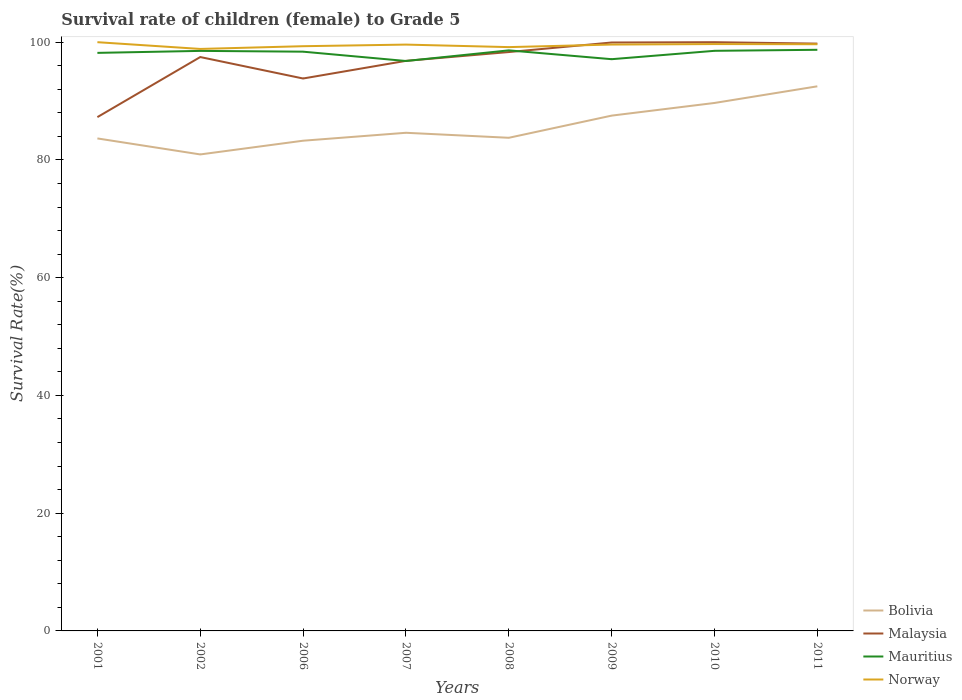How many different coloured lines are there?
Offer a very short reply. 4. Is the number of lines equal to the number of legend labels?
Give a very brief answer. Yes. Across all years, what is the maximum survival rate of female children to grade 5 in Norway?
Provide a short and direct response. 98.85. In which year was the survival rate of female children to grade 5 in Mauritius maximum?
Make the answer very short. 2007. What is the total survival rate of female children to grade 5 in Norway in the graph?
Your response must be concise. -0.06. What is the difference between the highest and the second highest survival rate of female children to grade 5 in Bolivia?
Your answer should be very brief. 11.57. What is the difference between two consecutive major ticks on the Y-axis?
Your response must be concise. 20. Where does the legend appear in the graph?
Make the answer very short. Bottom right. How many legend labels are there?
Your answer should be compact. 4. How are the legend labels stacked?
Keep it short and to the point. Vertical. What is the title of the graph?
Make the answer very short. Survival rate of children (female) to Grade 5. Does "Finland" appear as one of the legend labels in the graph?
Offer a very short reply. No. What is the label or title of the Y-axis?
Offer a terse response. Survival Rate(%). What is the Survival Rate(%) of Bolivia in 2001?
Offer a very short reply. 83.65. What is the Survival Rate(%) of Malaysia in 2001?
Offer a very short reply. 87.27. What is the Survival Rate(%) in Mauritius in 2001?
Ensure brevity in your answer.  98.19. What is the Survival Rate(%) of Bolivia in 2002?
Your response must be concise. 80.94. What is the Survival Rate(%) in Malaysia in 2002?
Your answer should be compact. 97.48. What is the Survival Rate(%) of Mauritius in 2002?
Offer a terse response. 98.52. What is the Survival Rate(%) of Norway in 2002?
Give a very brief answer. 98.85. What is the Survival Rate(%) of Bolivia in 2006?
Your response must be concise. 83.26. What is the Survival Rate(%) in Malaysia in 2006?
Offer a terse response. 93.83. What is the Survival Rate(%) in Mauritius in 2006?
Provide a succinct answer. 98.39. What is the Survival Rate(%) of Norway in 2006?
Give a very brief answer. 99.32. What is the Survival Rate(%) in Bolivia in 2007?
Your answer should be compact. 84.61. What is the Survival Rate(%) of Malaysia in 2007?
Your response must be concise. 96.83. What is the Survival Rate(%) in Mauritius in 2007?
Provide a short and direct response. 96.81. What is the Survival Rate(%) in Norway in 2007?
Ensure brevity in your answer.  99.59. What is the Survival Rate(%) in Bolivia in 2008?
Keep it short and to the point. 83.76. What is the Survival Rate(%) in Malaysia in 2008?
Your response must be concise. 98.32. What is the Survival Rate(%) of Mauritius in 2008?
Your answer should be compact. 98.61. What is the Survival Rate(%) in Norway in 2008?
Offer a very short reply. 99.16. What is the Survival Rate(%) in Bolivia in 2009?
Offer a terse response. 87.53. What is the Survival Rate(%) of Malaysia in 2009?
Give a very brief answer. 99.95. What is the Survival Rate(%) in Mauritius in 2009?
Offer a terse response. 97.11. What is the Survival Rate(%) in Norway in 2009?
Your answer should be compact. 99.6. What is the Survival Rate(%) of Bolivia in 2010?
Offer a very short reply. 89.68. What is the Survival Rate(%) in Mauritius in 2010?
Give a very brief answer. 98.53. What is the Survival Rate(%) of Norway in 2010?
Your answer should be compact. 99.68. What is the Survival Rate(%) in Bolivia in 2011?
Offer a terse response. 92.5. What is the Survival Rate(%) in Malaysia in 2011?
Offer a very short reply. 99.76. What is the Survival Rate(%) of Mauritius in 2011?
Provide a short and direct response. 98.71. What is the Survival Rate(%) of Norway in 2011?
Keep it short and to the point. 99.65. Across all years, what is the maximum Survival Rate(%) in Bolivia?
Make the answer very short. 92.5. Across all years, what is the maximum Survival Rate(%) in Malaysia?
Provide a short and direct response. 100. Across all years, what is the maximum Survival Rate(%) of Mauritius?
Ensure brevity in your answer.  98.71. Across all years, what is the maximum Survival Rate(%) in Norway?
Give a very brief answer. 100. Across all years, what is the minimum Survival Rate(%) in Bolivia?
Provide a short and direct response. 80.94. Across all years, what is the minimum Survival Rate(%) in Malaysia?
Your answer should be very brief. 87.27. Across all years, what is the minimum Survival Rate(%) in Mauritius?
Keep it short and to the point. 96.81. Across all years, what is the minimum Survival Rate(%) of Norway?
Your answer should be compact. 98.85. What is the total Survival Rate(%) of Bolivia in the graph?
Ensure brevity in your answer.  685.94. What is the total Survival Rate(%) in Malaysia in the graph?
Your answer should be very brief. 773.44. What is the total Survival Rate(%) in Mauritius in the graph?
Keep it short and to the point. 784.87. What is the total Survival Rate(%) in Norway in the graph?
Make the answer very short. 795.86. What is the difference between the Survival Rate(%) in Bolivia in 2001 and that in 2002?
Offer a very short reply. 2.72. What is the difference between the Survival Rate(%) of Malaysia in 2001 and that in 2002?
Offer a terse response. -10.2. What is the difference between the Survival Rate(%) of Mauritius in 2001 and that in 2002?
Your answer should be compact. -0.34. What is the difference between the Survival Rate(%) of Norway in 2001 and that in 2002?
Your response must be concise. 1.15. What is the difference between the Survival Rate(%) of Bolivia in 2001 and that in 2006?
Keep it short and to the point. 0.39. What is the difference between the Survival Rate(%) of Malaysia in 2001 and that in 2006?
Offer a terse response. -6.56. What is the difference between the Survival Rate(%) in Mauritius in 2001 and that in 2006?
Offer a very short reply. -0.2. What is the difference between the Survival Rate(%) in Norway in 2001 and that in 2006?
Ensure brevity in your answer.  0.68. What is the difference between the Survival Rate(%) of Bolivia in 2001 and that in 2007?
Your response must be concise. -0.96. What is the difference between the Survival Rate(%) in Malaysia in 2001 and that in 2007?
Provide a short and direct response. -9.56. What is the difference between the Survival Rate(%) of Mauritius in 2001 and that in 2007?
Make the answer very short. 1.38. What is the difference between the Survival Rate(%) in Norway in 2001 and that in 2007?
Keep it short and to the point. 0.41. What is the difference between the Survival Rate(%) in Bolivia in 2001 and that in 2008?
Make the answer very short. -0.11. What is the difference between the Survival Rate(%) of Malaysia in 2001 and that in 2008?
Your answer should be compact. -11.05. What is the difference between the Survival Rate(%) of Mauritius in 2001 and that in 2008?
Make the answer very short. -0.42. What is the difference between the Survival Rate(%) in Norway in 2001 and that in 2008?
Make the answer very short. 0.84. What is the difference between the Survival Rate(%) of Bolivia in 2001 and that in 2009?
Make the answer very short. -3.88. What is the difference between the Survival Rate(%) in Malaysia in 2001 and that in 2009?
Your response must be concise. -12.67. What is the difference between the Survival Rate(%) in Mauritius in 2001 and that in 2009?
Provide a succinct answer. 1.07. What is the difference between the Survival Rate(%) of Norway in 2001 and that in 2009?
Your answer should be very brief. 0.4. What is the difference between the Survival Rate(%) of Bolivia in 2001 and that in 2010?
Your response must be concise. -6.02. What is the difference between the Survival Rate(%) in Malaysia in 2001 and that in 2010?
Keep it short and to the point. -12.73. What is the difference between the Survival Rate(%) in Mauritius in 2001 and that in 2010?
Provide a succinct answer. -0.35. What is the difference between the Survival Rate(%) of Norway in 2001 and that in 2010?
Your response must be concise. 0.32. What is the difference between the Survival Rate(%) of Bolivia in 2001 and that in 2011?
Offer a terse response. -8.85. What is the difference between the Survival Rate(%) of Malaysia in 2001 and that in 2011?
Offer a very short reply. -12.48. What is the difference between the Survival Rate(%) of Mauritius in 2001 and that in 2011?
Make the answer very short. -0.52. What is the difference between the Survival Rate(%) of Norway in 2001 and that in 2011?
Offer a terse response. 0.35. What is the difference between the Survival Rate(%) of Bolivia in 2002 and that in 2006?
Your answer should be compact. -2.33. What is the difference between the Survival Rate(%) of Malaysia in 2002 and that in 2006?
Provide a short and direct response. 3.64. What is the difference between the Survival Rate(%) of Mauritius in 2002 and that in 2006?
Offer a very short reply. 0.13. What is the difference between the Survival Rate(%) of Norway in 2002 and that in 2006?
Provide a succinct answer. -0.46. What is the difference between the Survival Rate(%) in Bolivia in 2002 and that in 2007?
Provide a short and direct response. -3.68. What is the difference between the Survival Rate(%) of Malaysia in 2002 and that in 2007?
Your answer should be very brief. 0.65. What is the difference between the Survival Rate(%) in Mauritius in 2002 and that in 2007?
Ensure brevity in your answer.  1.72. What is the difference between the Survival Rate(%) in Norway in 2002 and that in 2007?
Offer a terse response. -0.74. What is the difference between the Survival Rate(%) of Bolivia in 2002 and that in 2008?
Ensure brevity in your answer.  -2.83. What is the difference between the Survival Rate(%) of Malaysia in 2002 and that in 2008?
Keep it short and to the point. -0.85. What is the difference between the Survival Rate(%) in Mauritius in 2002 and that in 2008?
Offer a very short reply. -0.09. What is the difference between the Survival Rate(%) in Norway in 2002 and that in 2008?
Your response must be concise. -0.31. What is the difference between the Survival Rate(%) in Bolivia in 2002 and that in 2009?
Keep it short and to the point. -6.59. What is the difference between the Survival Rate(%) of Malaysia in 2002 and that in 2009?
Offer a very short reply. -2.47. What is the difference between the Survival Rate(%) in Mauritius in 2002 and that in 2009?
Offer a very short reply. 1.41. What is the difference between the Survival Rate(%) of Norway in 2002 and that in 2009?
Offer a very short reply. -0.74. What is the difference between the Survival Rate(%) of Bolivia in 2002 and that in 2010?
Ensure brevity in your answer.  -8.74. What is the difference between the Survival Rate(%) in Malaysia in 2002 and that in 2010?
Ensure brevity in your answer.  -2.52. What is the difference between the Survival Rate(%) of Mauritius in 2002 and that in 2010?
Make the answer very short. -0.01. What is the difference between the Survival Rate(%) of Norway in 2002 and that in 2010?
Provide a short and direct response. -0.83. What is the difference between the Survival Rate(%) of Bolivia in 2002 and that in 2011?
Ensure brevity in your answer.  -11.57. What is the difference between the Survival Rate(%) in Malaysia in 2002 and that in 2011?
Provide a succinct answer. -2.28. What is the difference between the Survival Rate(%) in Mauritius in 2002 and that in 2011?
Offer a very short reply. -0.19. What is the difference between the Survival Rate(%) in Norway in 2002 and that in 2011?
Keep it short and to the point. -0.8. What is the difference between the Survival Rate(%) of Bolivia in 2006 and that in 2007?
Your response must be concise. -1.35. What is the difference between the Survival Rate(%) of Malaysia in 2006 and that in 2007?
Your response must be concise. -3. What is the difference between the Survival Rate(%) in Mauritius in 2006 and that in 2007?
Make the answer very short. 1.58. What is the difference between the Survival Rate(%) of Norway in 2006 and that in 2007?
Offer a terse response. -0.27. What is the difference between the Survival Rate(%) in Bolivia in 2006 and that in 2008?
Your answer should be compact. -0.5. What is the difference between the Survival Rate(%) of Malaysia in 2006 and that in 2008?
Your answer should be compact. -4.49. What is the difference between the Survival Rate(%) in Mauritius in 2006 and that in 2008?
Your response must be concise. -0.22. What is the difference between the Survival Rate(%) of Norway in 2006 and that in 2008?
Provide a succinct answer. 0.15. What is the difference between the Survival Rate(%) in Bolivia in 2006 and that in 2009?
Your answer should be very brief. -4.26. What is the difference between the Survival Rate(%) of Malaysia in 2006 and that in 2009?
Keep it short and to the point. -6.11. What is the difference between the Survival Rate(%) of Mauritius in 2006 and that in 2009?
Offer a terse response. 1.28. What is the difference between the Survival Rate(%) of Norway in 2006 and that in 2009?
Provide a short and direct response. -0.28. What is the difference between the Survival Rate(%) of Bolivia in 2006 and that in 2010?
Your response must be concise. -6.41. What is the difference between the Survival Rate(%) in Malaysia in 2006 and that in 2010?
Ensure brevity in your answer.  -6.17. What is the difference between the Survival Rate(%) of Mauritius in 2006 and that in 2010?
Offer a terse response. -0.15. What is the difference between the Survival Rate(%) of Norway in 2006 and that in 2010?
Your answer should be very brief. -0.36. What is the difference between the Survival Rate(%) of Bolivia in 2006 and that in 2011?
Ensure brevity in your answer.  -9.24. What is the difference between the Survival Rate(%) in Malaysia in 2006 and that in 2011?
Provide a short and direct response. -5.93. What is the difference between the Survival Rate(%) in Mauritius in 2006 and that in 2011?
Ensure brevity in your answer.  -0.32. What is the difference between the Survival Rate(%) in Norway in 2006 and that in 2011?
Provide a short and direct response. -0.33. What is the difference between the Survival Rate(%) in Bolivia in 2007 and that in 2008?
Ensure brevity in your answer.  0.85. What is the difference between the Survival Rate(%) in Malaysia in 2007 and that in 2008?
Offer a terse response. -1.49. What is the difference between the Survival Rate(%) of Mauritius in 2007 and that in 2008?
Make the answer very short. -1.8. What is the difference between the Survival Rate(%) in Norway in 2007 and that in 2008?
Your response must be concise. 0.43. What is the difference between the Survival Rate(%) in Bolivia in 2007 and that in 2009?
Offer a terse response. -2.92. What is the difference between the Survival Rate(%) in Malaysia in 2007 and that in 2009?
Your answer should be very brief. -3.12. What is the difference between the Survival Rate(%) of Mauritius in 2007 and that in 2009?
Offer a terse response. -0.31. What is the difference between the Survival Rate(%) of Norway in 2007 and that in 2009?
Your answer should be very brief. -0.01. What is the difference between the Survival Rate(%) of Bolivia in 2007 and that in 2010?
Offer a terse response. -5.06. What is the difference between the Survival Rate(%) in Malaysia in 2007 and that in 2010?
Offer a terse response. -3.17. What is the difference between the Survival Rate(%) of Mauritius in 2007 and that in 2010?
Offer a very short reply. -1.73. What is the difference between the Survival Rate(%) of Norway in 2007 and that in 2010?
Give a very brief answer. -0.09. What is the difference between the Survival Rate(%) in Bolivia in 2007 and that in 2011?
Make the answer very short. -7.89. What is the difference between the Survival Rate(%) of Malaysia in 2007 and that in 2011?
Ensure brevity in your answer.  -2.93. What is the difference between the Survival Rate(%) of Mauritius in 2007 and that in 2011?
Provide a short and direct response. -1.9. What is the difference between the Survival Rate(%) in Norway in 2007 and that in 2011?
Ensure brevity in your answer.  -0.06. What is the difference between the Survival Rate(%) in Bolivia in 2008 and that in 2009?
Your response must be concise. -3.77. What is the difference between the Survival Rate(%) of Malaysia in 2008 and that in 2009?
Offer a very short reply. -1.62. What is the difference between the Survival Rate(%) of Mauritius in 2008 and that in 2009?
Your answer should be very brief. 1.5. What is the difference between the Survival Rate(%) of Norway in 2008 and that in 2009?
Your answer should be very brief. -0.44. What is the difference between the Survival Rate(%) of Bolivia in 2008 and that in 2010?
Your answer should be compact. -5.91. What is the difference between the Survival Rate(%) of Malaysia in 2008 and that in 2010?
Offer a very short reply. -1.68. What is the difference between the Survival Rate(%) of Mauritius in 2008 and that in 2010?
Offer a very short reply. 0.08. What is the difference between the Survival Rate(%) in Norway in 2008 and that in 2010?
Ensure brevity in your answer.  -0.52. What is the difference between the Survival Rate(%) in Bolivia in 2008 and that in 2011?
Make the answer very short. -8.74. What is the difference between the Survival Rate(%) of Malaysia in 2008 and that in 2011?
Make the answer very short. -1.43. What is the difference between the Survival Rate(%) in Mauritius in 2008 and that in 2011?
Offer a terse response. -0.1. What is the difference between the Survival Rate(%) of Norway in 2008 and that in 2011?
Your answer should be very brief. -0.49. What is the difference between the Survival Rate(%) of Bolivia in 2009 and that in 2010?
Make the answer very short. -2.15. What is the difference between the Survival Rate(%) of Malaysia in 2009 and that in 2010?
Provide a succinct answer. -0.05. What is the difference between the Survival Rate(%) in Mauritius in 2009 and that in 2010?
Give a very brief answer. -1.42. What is the difference between the Survival Rate(%) in Norway in 2009 and that in 2010?
Your answer should be compact. -0.08. What is the difference between the Survival Rate(%) of Bolivia in 2009 and that in 2011?
Provide a short and direct response. -4.98. What is the difference between the Survival Rate(%) of Malaysia in 2009 and that in 2011?
Ensure brevity in your answer.  0.19. What is the difference between the Survival Rate(%) of Mauritius in 2009 and that in 2011?
Provide a short and direct response. -1.6. What is the difference between the Survival Rate(%) of Norway in 2009 and that in 2011?
Make the answer very short. -0.05. What is the difference between the Survival Rate(%) of Bolivia in 2010 and that in 2011?
Your answer should be very brief. -2.83. What is the difference between the Survival Rate(%) in Malaysia in 2010 and that in 2011?
Offer a terse response. 0.24. What is the difference between the Survival Rate(%) in Mauritius in 2010 and that in 2011?
Your answer should be very brief. -0.17. What is the difference between the Survival Rate(%) in Norway in 2010 and that in 2011?
Your response must be concise. 0.03. What is the difference between the Survival Rate(%) in Bolivia in 2001 and the Survival Rate(%) in Malaysia in 2002?
Give a very brief answer. -13.82. What is the difference between the Survival Rate(%) in Bolivia in 2001 and the Survival Rate(%) in Mauritius in 2002?
Offer a terse response. -14.87. What is the difference between the Survival Rate(%) in Bolivia in 2001 and the Survival Rate(%) in Norway in 2002?
Your answer should be very brief. -15.2. What is the difference between the Survival Rate(%) of Malaysia in 2001 and the Survival Rate(%) of Mauritius in 2002?
Your answer should be very brief. -11.25. What is the difference between the Survival Rate(%) in Malaysia in 2001 and the Survival Rate(%) in Norway in 2002?
Give a very brief answer. -11.58. What is the difference between the Survival Rate(%) in Mauritius in 2001 and the Survival Rate(%) in Norway in 2002?
Keep it short and to the point. -0.67. What is the difference between the Survival Rate(%) in Bolivia in 2001 and the Survival Rate(%) in Malaysia in 2006?
Your answer should be compact. -10.18. What is the difference between the Survival Rate(%) in Bolivia in 2001 and the Survival Rate(%) in Mauritius in 2006?
Offer a terse response. -14.74. What is the difference between the Survival Rate(%) of Bolivia in 2001 and the Survival Rate(%) of Norway in 2006?
Your answer should be very brief. -15.66. What is the difference between the Survival Rate(%) of Malaysia in 2001 and the Survival Rate(%) of Mauritius in 2006?
Your answer should be very brief. -11.12. What is the difference between the Survival Rate(%) of Malaysia in 2001 and the Survival Rate(%) of Norway in 2006?
Your answer should be very brief. -12.04. What is the difference between the Survival Rate(%) in Mauritius in 2001 and the Survival Rate(%) in Norway in 2006?
Provide a succinct answer. -1.13. What is the difference between the Survival Rate(%) in Bolivia in 2001 and the Survival Rate(%) in Malaysia in 2007?
Provide a succinct answer. -13.18. What is the difference between the Survival Rate(%) in Bolivia in 2001 and the Survival Rate(%) in Mauritius in 2007?
Your response must be concise. -13.15. What is the difference between the Survival Rate(%) of Bolivia in 2001 and the Survival Rate(%) of Norway in 2007?
Provide a succinct answer. -15.94. What is the difference between the Survival Rate(%) of Malaysia in 2001 and the Survival Rate(%) of Mauritius in 2007?
Give a very brief answer. -9.53. What is the difference between the Survival Rate(%) in Malaysia in 2001 and the Survival Rate(%) in Norway in 2007?
Provide a short and direct response. -12.32. What is the difference between the Survival Rate(%) in Mauritius in 2001 and the Survival Rate(%) in Norway in 2007?
Your response must be concise. -1.41. What is the difference between the Survival Rate(%) in Bolivia in 2001 and the Survival Rate(%) in Malaysia in 2008?
Your answer should be very brief. -14.67. What is the difference between the Survival Rate(%) of Bolivia in 2001 and the Survival Rate(%) of Mauritius in 2008?
Keep it short and to the point. -14.96. What is the difference between the Survival Rate(%) in Bolivia in 2001 and the Survival Rate(%) in Norway in 2008?
Provide a short and direct response. -15.51. What is the difference between the Survival Rate(%) in Malaysia in 2001 and the Survival Rate(%) in Mauritius in 2008?
Provide a short and direct response. -11.34. What is the difference between the Survival Rate(%) in Malaysia in 2001 and the Survival Rate(%) in Norway in 2008?
Ensure brevity in your answer.  -11.89. What is the difference between the Survival Rate(%) of Mauritius in 2001 and the Survival Rate(%) of Norway in 2008?
Give a very brief answer. -0.98. What is the difference between the Survival Rate(%) of Bolivia in 2001 and the Survival Rate(%) of Malaysia in 2009?
Your answer should be compact. -16.29. What is the difference between the Survival Rate(%) of Bolivia in 2001 and the Survival Rate(%) of Mauritius in 2009?
Your answer should be very brief. -13.46. What is the difference between the Survival Rate(%) of Bolivia in 2001 and the Survival Rate(%) of Norway in 2009?
Give a very brief answer. -15.95. What is the difference between the Survival Rate(%) of Malaysia in 2001 and the Survival Rate(%) of Mauritius in 2009?
Keep it short and to the point. -9.84. What is the difference between the Survival Rate(%) of Malaysia in 2001 and the Survival Rate(%) of Norway in 2009?
Ensure brevity in your answer.  -12.33. What is the difference between the Survival Rate(%) of Mauritius in 2001 and the Survival Rate(%) of Norway in 2009?
Make the answer very short. -1.41. What is the difference between the Survival Rate(%) in Bolivia in 2001 and the Survival Rate(%) in Malaysia in 2010?
Your response must be concise. -16.35. What is the difference between the Survival Rate(%) of Bolivia in 2001 and the Survival Rate(%) of Mauritius in 2010?
Keep it short and to the point. -14.88. What is the difference between the Survival Rate(%) in Bolivia in 2001 and the Survival Rate(%) in Norway in 2010?
Your answer should be very brief. -16.03. What is the difference between the Survival Rate(%) of Malaysia in 2001 and the Survival Rate(%) of Mauritius in 2010?
Keep it short and to the point. -11.26. What is the difference between the Survival Rate(%) of Malaysia in 2001 and the Survival Rate(%) of Norway in 2010?
Offer a terse response. -12.41. What is the difference between the Survival Rate(%) of Mauritius in 2001 and the Survival Rate(%) of Norway in 2010?
Your answer should be compact. -1.49. What is the difference between the Survival Rate(%) in Bolivia in 2001 and the Survival Rate(%) in Malaysia in 2011?
Ensure brevity in your answer.  -16.1. What is the difference between the Survival Rate(%) of Bolivia in 2001 and the Survival Rate(%) of Mauritius in 2011?
Offer a very short reply. -15.06. What is the difference between the Survival Rate(%) of Bolivia in 2001 and the Survival Rate(%) of Norway in 2011?
Keep it short and to the point. -16. What is the difference between the Survival Rate(%) of Malaysia in 2001 and the Survival Rate(%) of Mauritius in 2011?
Your answer should be compact. -11.44. What is the difference between the Survival Rate(%) in Malaysia in 2001 and the Survival Rate(%) in Norway in 2011?
Keep it short and to the point. -12.38. What is the difference between the Survival Rate(%) in Mauritius in 2001 and the Survival Rate(%) in Norway in 2011?
Provide a succinct answer. -1.47. What is the difference between the Survival Rate(%) in Bolivia in 2002 and the Survival Rate(%) in Malaysia in 2006?
Your response must be concise. -12.9. What is the difference between the Survival Rate(%) of Bolivia in 2002 and the Survival Rate(%) of Mauritius in 2006?
Your answer should be compact. -17.45. What is the difference between the Survival Rate(%) of Bolivia in 2002 and the Survival Rate(%) of Norway in 2006?
Keep it short and to the point. -18.38. What is the difference between the Survival Rate(%) in Malaysia in 2002 and the Survival Rate(%) in Mauritius in 2006?
Offer a terse response. -0.91. What is the difference between the Survival Rate(%) of Malaysia in 2002 and the Survival Rate(%) of Norway in 2006?
Keep it short and to the point. -1.84. What is the difference between the Survival Rate(%) in Mauritius in 2002 and the Survival Rate(%) in Norway in 2006?
Provide a succinct answer. -0.79. What is the difference between the Survival Rate(%) of Bolivia in 2002 and the Survival Rate(%) of Malaysia in 2007?
Offer a terse response. -15.89. What is the difference between the Survival Rate(%) in Bolivia in 2002 and the Survival Rate(%) in Mauritius in 2007?
Your answer should be very brief. -15.87. What is the difference between the Survival Rate(%) of Bolivia in 2002 and the Survival Rate(%) of Norway in 2007?
Your answer should be very brief. -18.66. What is the difference between the Survival Rate(%) in Malaysia in 2002 and the Survival Rate(%) in Mauritius in 2007?
Keep it short and to the point. 0.67. What is the difference between the Survival Rate(%) of Malaysia in 2002 and the Survival Rate(%) of Norway in 2007?
Keep it short and to the point. -2.12. What is the difference between the Survival Rate(%) of Mauritius in 2002 and the Survival Rate(%) of Norway in 2007?
Give a very brief answer. -1.07. What is the difference between the Survival Rate(%) in Bolivia in 2002 and the Survival Rate(%) in Malaysia in 2008?
Provide a short and direct response. -17.39. What is the difference between the Survival Rate(%) in Bolivia in 2002 and the Survival Rate(%) in Mauritius in 2008?
Provide a succinct answer. -17.67. What is the difference between the Survival Rate(%) of Bolivia in 2002 and the Survival Rate(%) of Norway in 2008?
Offer a terse response. -18.23. What is the difference between the Survival Rate(%) in Malaysia in 2002 and the Survival Rate(%) in Mauritius in 2008?
Your response must be concise. -1.13. What is the difference between the Survival Rate(%) in Malaysia in 2002 and the Survival Rate(%) in Norway in 2008?
Provide a succinct answer. -1.69. What is the difference between the Survival Rate(%) of Mauritius in 2002 and the Survival Rate(%) of Norway in 2008?
Offer a very short reply. -0.64. What is the difference between the Survival Rate(%) in Bolivia in 2002 and the Survival Rate(%) in Malaysia in 2009?
Your answer should be compact. -19.01. What is the difference between the Survival Rate(%) of Bolivia in 2002 and the Survival Rate(%) of Mauritius in 2009?
Ensure brevity in your answer.  -16.18. What is the difference between the Survival Rate(%) of Bolivia in 2002 and the Survival Rate(%) of Norway in 2009?
Offer a very short reply. -18.66. What is the difference between the Survival Rate(%) in Malaysia in 2002 and the Survival Rate(%) in Mauritius in 2009?
Offer a very short reply. 0.36. What is the difference between the Survival Rate(%) of Malaysia in 2002 and the Survival Rate(%) of Norway in 2009?
Provide a short and direct response. -2.12. What is the difference between the Survival Rate(%) in Mauritius in 2002 and the Survival Rate(%) in Norway in 2009?
Provide a short and direct response. -1.08. What is the difference between the Survival Rate(%) in Bolivia in 2002 and the Survival Rate(%) in Malaysia in 2010?
Make the answer very short. -19.06. What is the difference between the Survival Rate(%) in Bolivia in 2002 and the Survival Rate(%) in Mauritius in 2010?
Offer a terse response. -17.6. What is the difference between the Survival Rate(%) of Bolivia in 2002 and the Survival Rate(%) of Norway in 2010?
Your answer should be compact. -18.74. What is the difference between the Survival Rate(%) of Malaysia in 2002 and the Survival Rate(%) of Mauritius in 2010?
Offer a very short reply. -1.06. What is the difference between the Survival Rate(%) of Malaysia in 2002 and the Survival Rate(%) of Norway in 2010?
Offer a terse response. -2.2. What is the difference between the Survival Rate(%) in Mauritius in 2002 and the Survival Rate(%) in Norway in 2010?
Provide a short and direct response. -1.16. What is the difference between the Survival Rate(%) in Bolivia in 2002 and the Survival Rate(%) in Malaysia in 2011?
Your response must be concise. -18.82. What is the difference between the Survival Rate(%) in Bolivia in 2002 and the Survival Rate(%) in Mauritius in 2011?
Give a very brief answer. -17.77. What is the difference between the Survival Rate(%) in Bolivia in 2002 and the Survival Rate(%) in Norway in 2011?
Offer a very short reply. -18.72. What is the difference between the Survival Rate(%) of Malaysia in 2002 and the Survival Rate(%) of Mauritius in 2011?
Provide a succinct answer. -1.23. What is the difference between the Survival Rate(%) of Malaysia in 2002 and the Survival Rate(%) of Norway in 2011?
Provide a short and direct response. -2.18. What is the difference between the Survival Rate(%) of Mauritius in 2002 and the Survival Rate(%) of Norway in 2011?
Provide a succinct answer. -1.13. What is the difference between the Survival Rate(%) of Bolivia in 2006 and the Survival Rate(%) of Malaysia in 2007?
Make the answer very short. -13.56. What is the difference between the Survival Rate(%) in Bolivia in 2006 and the Survival Rate(%) in Mauritius in 2007?
Your response must be concise. -13.54. What is the difference between the Survival Rate(%) of Bolivia in 2006 and the Survival Rate(%) of Norway in 2007?
Provide a short and direct response. -16.33. What is the difference between the Survival Rate(%) in Malaysia in 2006 and the Survival Rate(%) in Mauritius in 2007?
Give a very brief answer. -2.97. What is the difference between the Survival Rate(%) of Malaysia in 2006 and the Survival Rate(%) of Norway in 2007?
Provide a short and direct response. -5.76. What is the difference between the Survival Rate(%) of Mauritius in 2006 and the Survival Rate(%) of Norway in 2007?
Your answer should be compact. -1.2. What is the difference between the Survival Rate(%) in Bolivia in 2006 and the Survival Rate(%) in Malaysia in 2008?
Offer a terse response. -15.06. What is the difference between the Survival Rate(%) in Bolivia in 2006 and the Survival Rate(%) in Mauritius in 2008?
Offer a very short reply. -15.34. What is the difference between the Survival Rate(%) of Bolivia in 2006 and the Survival Rate(%) of Norway in 2008?
Your answer should be compact. -15.9. What is the difference between the Survival Rate(%) in Malaysia in 2006 and the Survival Rate(%) in Mauritius in 2008?
Your answer should be very brief. -4.78. What is the difference between the Survival Rate(%) of Malaysia in 2006 and the Survival Rate(%) of Norway in 2008?
Ensure brevity in your answer.  -5.33. What is the difference between the Survival Rate(%) of Mauritius in 2006 and the Survival Rate(%) of Norway in 2008?
Keep it short and to the point. -0.78. What is the difference between the Survival Rate(%) of Bolivia in 2006 and the Survival Rate(%) of Malaysia in 2009?
Offer a very short reply. -16.68. What is the difference between the Survival Rate(%) of Bolivia in 2006 and the Survival Rate(%) of Mauritius in 2009?
Provide a short and direct response. -13.85. What is the difference between the Survival Rate(%) of Bolivia in 2006 and the Survival Rate(%) of Norway in 2009?
Your answer should be very brief. -16.33. What is the difference between the Survival Rate(%) in Malaysia in 2006 and the Survival Rate(%) in Mauritius in 2009?
Ensure brevity in your answer.  -3.28. What is the difference between the Survival Rate(%) of Malaysia in 2006 and the Survival Rate(%) of Norway in 2009?
Offer a very short reply. -5.77. What is the difference between the Survival Rate(%) of Mauritius in 2006 and the Survival Rate(%) of Norway in 2009?
Provide a succinct answer. -1.21. What is the difference between the Survival Rate(%) of Bolivia in 2006 and the Survival Rate(%) of Malaysia in 2010?
Your answer should be compact. -16.74. What is the difference between the Survival Rate(%) of Bolivia in 2006 and the Survival Rate(%) of Mauritius in 2010?
Offer a terse response. -15.27. What is the difference between the Survival Rate(%) of Bolivia in 2006 and the Survival Rate(%) of Norway in 2010?
Provide a short and direct response. -16.42. What is the difference between the Survival Rate(%) of Malaysia in 2006 and the Survival Rate(%) of Mauritius in 2010?
Keep it short and to the point. -4.7. What is the difference between the Survival Rate(%) in Malaysia in 2006 and the Survival Rate(%) in Norway in 2010?
Offer a terse response. -5.85. What is the difference between the Survival Rate(%) of Mauritius in 2006 and the Survival Rate(%) of Norway in 2010?
Your answer should be compact. -1.29. What is the difference between the Survival Rate(%) of Bolivia in 2006 and the Survival Rate(%) of Malaysia in 2011?
Your response must be concise. -16.49. What is the difference between the Survival Rate(%) of Bolivia in 2006 and the Survival Rate(%) of Mauritius in 2011?
Provide a succinct answer. -15.44. What is the difference between the Survival Rate(%) of Bolivia in 2006 and the Survival Rate(%) of Norway in 2011?
Ensure brevity in your answer.  -16.39. What is the difference between the Survival Rate(%) of Malaysia in 2006 and the Survival Rate(%) of Mauritius in 2011?
Ensure brevity in your answer.  -4.88. What is the difference between the Survival Rate(%) of Malaysia in 2006 and the Survival Rate(%) of Norway in 2011?
Ensure brevity in your answer.  -5.82. What is the difference between the Survival Rate(%) of Mauritius in 2006 and the Survival Rate(%) of Norway in 2011?
Keep it short and to the point. -1.26. What is the difference between the Survival Rate(%) of Bolivia in 2007 and the Survival Rate(%) of Malaysia in 2008?
Your answer should be very brief. -13.71. What is the difference between the Survival Rate(%) in Bolivia in 2007 and the Survival Rate(%) in Mauritius in 2008?
Provide a succinct answer. -14. What is the difference between the Survival Rate(%) in Bolivia in 2007 and the Survival Rate(%) in Norway in 2008?
Offer a very short reply. -14.55. What is the difference between the Survival Rate(%) in Malaysia in 2007 and the Survival Rate(%) in Mauritius in 2008?
Keep it short and to the point. -1.78. What is the difference between the Survival Rate(%) in Malaysia in 2007 and the Survival Rate(%) in Norway in 2008?
Offer a terse response. -2.33. What is the difference between the Survival Rate(%) in Mauritius in 2007 and the Survival Rate(%) in Norway in 2008?
Make the answer very short. -2.36. What is the difference between the Survival Rate(%) of Bolivia in 2007 and the Survival Rate(%) of Malaysia in 2009?
Provide a succinct answer. -15.33. What is the difference between the Survival Rate(%) in Bolivia in 2007 and the Survival Rate(%) in Mauritius in 2009?
Make the answer very short. -12.5. What is the difference between the Survival Rate(%) of Bolivia in 2007 and the Survival Rate(%) of Norway in 2009?
Provide a short and direct response. -14.99. What is the difference between the Survival Rate(%) in Malaysia in 2007 and the Survival Rate(%) in Mauritius in 2009?
Provide a short and direct response. -0.28. What is the difference between the Survival Rate(%) in Malaysia in 2007 and the Survival Rate(%) in Norway in 2009?
Ensure brevity in your answer.  -2.77. What is the difference between the Survival Rate(%) of Mauritius in 2007 and the Survival Rate(%) of Norway in 2009?
Give a very brief answer. -2.79. What is the difference between the Survival Rate(%) in Bolivia in 2007 and the Survival Rate(%) in Malaysia in 2010?
Provide a short and direct response. -15.39. What is the difference between the Survival Rate(%) of Bolivia in 2007 and the Survival Rate(%) of Mauritius in 2010?
Your answer should be compact. -13.92. What is the difference between the Survival Rate(%) in Bolivia in 2007 and the Survival Rate(%) in Norway in 2010?
Give a very brief answer. -15.07. What is the difference between the Survival Rate(%) in Malaysia in 2007 and the Survival Rate(%) in Mauritius in 2010?
Provide a succinct answer. -1.7. What is the difference between the Survival Rate(%) in Malaysia in 2007 and the Survival Rate(%) in Norway in 2010?
Your answer should be compact. -2.85. What is the difference between the Survival Rate(%) of Mauritius in 2007 and the Survival Rate(%) of Norway in 2010?
Your response must be concise. -2.87. What is the difference between the Survival Rate(%) of Bolivia in 2007 and the Survival Rate(%) of Malaysia in 2011?
Ensure brevity in your answer.  -15.14. What is the difference between the Survival Rate(%) in Bolivia in 2007 and the Survival Rate(%) in Mauritius in 2011?
Give a very brief answer. -14.1. What is the difference between the Survival Rate(%) in Bolivia in 2007 and the Survival Rate(%) in Norway in 2011?
Ensure brevity in your answer.  -15.04. What is the difference between the Survival Rate(%) of Malaysia in 2007 and the Survival Rate(%) of Mauritius in 2011?
Make the answer very short. -1.88. What is the difference between the Survival Rate(%) of Malaysia in 2007 and the Survival Rate(%) of Norway in 2011?
Your answer should be compact. -2.82. What is the difference between the Survival Rate(%) in Mauritius in 2007 and the Survival Rate(%) in Norway in 2011?
Your answer should be compact. -2.85. What is the difference between the Survival Rate(%) of Bolivia in 2008 and the Survival Rate(%) of Malaysia in 2009?
Provide a short and direct response. -16.18. What is the difference between the Survival Rate(%) in Bolivia in 2008 and the Survival Rate(%) in Mauritius in 2009?
Ensure brevity in your answer.  -13.35. What is the difference between the Survival Rate(%) of Bolivia in 2008 and the Survival Rate(%) of Norway in 2009?
Provide a short and direct response. -15.84. What is the difference between the Survival Rate(%) in Malaysia in 2008 and the Survival Rate(%) in Mauritius in 2009?
Keep it short and to the point. 1.21. What is the difference between the Survival Rate(%) in Malaysia in 2008 and the Survival Rate(%) in Norway in 2009?
Provide a succinct answer. -1.27. What is the difference between the Survival Rate(%) in Mauritius in 2008 and the Survival Rate(%) in Norway in 2009?
Your answer should be compact. -0.99. What is the difference between the Survival Rate(%) of Bolivia in 2008 and the Survival Rate(%) of Malaysia in 2010?
Offer a terse response. -16.24. What is the difference between the Survival Rate(%) in Bolivia in 2008 and the Survival Rate(%) in Mauritius in 2010?
Provide a succinct answer. -14.77. What is the difference between the Survival Rate(%) of Bolivia in 2008 and the Survival Rate(%) of Norway in 2010?
Make the answer very short. -15.92. What is the difference between the Survival Rate(%) of Malaysia in 2008 and the Survival Rate(%) of Mauritius in 2010?
Make the answer very short. -0.21. What is the difference between the Survival Rate(%) of Malaysia in 2008 and the Survival Rate(%) of Norway in 2010?
Make the answer very short. -1.36. What is the difference between the Survival Rate(%) in Mauritius in 2008 and the Survival Rate(%) in Norway in 2010?
Offer a very short reply. -1.07. What is the difference between the Survival Rate(%) of Bolivia in 2008 and the Survival Rate(%) of Malaysia in 2011?
Provide a succinct answer. -16. What is the difference between the Survival Rate(%) in Bolivia in 2008 and the Survival Rate(%) in Mauritius in 2011?
Provide a succinct answer. -14.95. What is the difference between the Survival Rate(%) in Bolivia in 2008 and the Survival Rate(%) in Norway in 2011?
Give a very brief answer. -15.89. What is the difference between the Survival Rate(%) of Malaysia in 2008 and the Survival Rate(%) of Mauritius in 2011?
Your answer should be very brief. -0.38. What is the difference between the Survival Rate(%) in Malaysia in 2008 and the Survival Rate(%) in Norway in 2011?
Keep it short and to the point. -1.33. What is the difference between the Survival Rate(%) of Mauritius in 2008 and the Survival Rate(%) of Norway in 2011?
Ensure brevity in your answer.  -1.04. What is the difference between the Survival Rate(%) in Bolivia in 2009 and the Survival Rate(%) in Malaysia in 2010?
Ensure brevity in your answer.  -12.47. What is the difference between the Survival Rate(%) of Bolivia in 2009 and the Survival Rate(%) of Mauritius in 2010?
Provide a short and direct response. -11.01. What is the difference between the Survival Rate(%) of Bolivia in 2009 and the Survival Rate(%) of Norway in 2010?
Offer a terse response. -12.15. What is the difference between the Survival Rate(%) of Malaysia in 2009 and the Survival Rate(%) of Mauritius in 2010?
Offer a very short reply. 1.41. What is the difference between the Survival Rate(%) of Malaysia in 2009 and the Survival Rate(%) of Norway in 2010?
Provide a succinct answer. 0.27. What is the difference between the Survival Rate(%) in Mauritius in 2009 and the Survival Rate(%) in Norway in 2010?
Give a very brief answer. -2.57. What is the difference between the Survival Rate(%) of Bolivia in 2009 and the Survival Rate(%) of Malaysia in 2011?
Make the answer very short. -12.23. What is the difference between the Survival Rate(%) in Bolivia in 2009 and the Survival Rate(%) in Mauritius in 2011?
Make the answer very short. -11.18. What is the difference between the Survival Rate(%) in Bolivia in 2009 and the Survival Rate(%) in Norway in 2011?
Offer a terse response. -12.12. What is the difference between the Survival Rate(%) of Malaysia in 2009 and the Survival Rate(%) of Mauritius in 2011?
Keep it short and to the point. 1.24. What is the difference between the Survival Rate(%) of Malaysia in 2009 and the Survival Rate(%) of Norway in 2011?
Ensure brevity in your answer.  0.3. What is the difference between the Survival Rate(%) of Mauritius in 2009 and the Survival Rate(%) of Norway in 2011?
Ensure brevity in your answer.  -2.54. What is the difference between the Survival Rate(%) in Bolivia in 2010 and the Survival Rate(%) in Malaysia in 2011?
Provide a short and direct response. -10.08. What is the difference between the Survival Rate(%) in Bolivia in 2010 and the Survival Rate(%) in Mauritius in 2011?
Your answer should be very brief. -9.03. What is the difference between the Survival Rate(%) of Bolivia in 2010 and the Survival Rate(%) of Norway in 2011?
Your response must be concise. -9.97. What is the difference between the Survival Rate(%) in Malaysia in 2010 and the Survival Rate(%) in Mauritius in 2011?
Give a very brief answer. 1.29. What is the difference between the Survival Rate(%) of Malaysia in 2010 and the Survival Rate(%) of Norway in 2011?
Keep it short and to the point. 0.35. What is the difference between the Survival Rate(%) of Mauritius in 2010 and the Survival Rate(%) of Norway in 2011?
Make the answer very short. -1.12. What is the average Survival Rate(%) of Bolivia per year?
Make the answer very short. 85.74. What is the average Survival Rate(%) of Malaysia per year?
Your answer should be very brief. 96.68. What is the average Survival Rate(%) in Mauritius per year?
Your answer should be compact. 98.11. What is the average Survival Rate(%) in Norway per year?
Your answer should be compact. 99.48. In the year 2001, what is the difference between the Survival Rate(%) in Bolivia and Survival Rate(%) in Malaysia?
Give a very brief answer. -3.62. In the year 2001, what is the difference between the Survival Rate(%) in Bolivia and Survival Rate(%) in Mauritius?
Make the answer very short. -14.53. In the year 2001, what is the difference between the Survival Rate(%) of Bolivia and Survival Rate(%) of Norway?
Provide a short and direct response. -16.35. In the year 2001, what is the difference between the Survival Rate(%) of Malaysia and Survival Rate(%) of Mauritius?
Make the answer very short. -10.91. In the year 2001, what is the difference between the Survival Rate(%) of Malaysia and Survival Rate(%) of Norway?
Your response must be concise. -12.73. In the year 2001, what is the difference between the Survival Rate(%) of Mauritius and Survival Rate(%) of Norway?
Provide a short and direct response. -1.81. In the year 2002, what is the difference between the Survival Rate(%) of Bolivia and Survival Rate(%) of Malaysia?
Provide a succinct answer. -16.54. In the year 2002, what is the difference between the Survival Rate(%) in Bolivia and Survival Rate(%) in Mauritius?
Your answer should be compact. -17.59. In the year 2002, what is the difference between the Survival Rate(%) of Bolivia and Survival Rate(%) of Norway?
Your response must be concise. -17.92. In the year 2002, what is the difference between the Survival Rate(%) in Malaysia and Survival Rate(%) in Mauritius?
Your response must be concise. -1.05. In the year 2002, what is the difference between the Survival Rate(%) of Malaysia and Survival Rate(%) of Norway?
Keep it short and to the point. -1.38. In the year 2002, what is the difference between the Survival Rate(%) of Mauritius and Survival Rate(%) of Norway?
Keep it short and to the point. -0.33. In the year 2006, what is the difference between the Survival Rate(%) of Bolivia and Survival Rate(%) of Malaysia?
Give a very brief answer. -10.57. In the year 2006, what is the difference between the Survival Rate(%) of Bolivia and Survival Rate(%) of Mauritius?
Make the answer very short. -15.12. In the year 2006, what is the difference between the Survival Rate(%) of Bolivia and Survival Rate(%) of Norway?
Your answer should be compact. -16.05. In the year 2006, what is the difference between the Survival Rate(%) in Malaysia and Survival Rate(%) in Mauritius?
Your answer should be very brief. -4.56. In the year 2006, what is the difference between the Survival Rate(%) in Malaysia and Survival Rate(%) in Norway?
Make the answer very short. -5.48. In the year 2006, what is the difference between the Survival Rate(%) of Mauritius and Survival Rate(%) of Norway?
Offer a very short reply. -0.93. In the year 2007, what is the difference between the Survival Rate(%) in Bolivia and Survival Rate(%) in Malaysia?
Your answer should be compact. -12.22. In the year 2007, what is the difference between the Survival Rate(%) of Bolivia and Survival Rate(%) of Mauritius?
Your answer should be compact. -12.19. In the year 2007, what is the difference between the Survival Rate(%) of Bolivia and Survival Rate(%) of Norway?
Your answer should be very brief. -14.98. In the year 2007, what is the difference between the Survival Rate(%) of Malaysia and Survival Rate(%) of Mauritius?
Keep it short and to the point. 0.02. In the year 2007, what is the difference between the Survival Rate(%) in Malaysia and Survival Rate(%) in Norway?
Offer a terse response. -2.76. In the year 2007, what is the difference between the Survival Rate(%) of Mauritius and Survival Rate(%) of Norway?
Offer a terse response. -2.79. In the year 2008, what is the difference between the Survival Rate(%) of Bolivia and Survival Rate(%) of Malaysia?
Give a very brief answer. -14.56. In the year 2008, what is the difference between the Survival Rate(%) in Bolivia and Survival Rate(%) in Mauritius?
Your answer should be compact. -14.85. In the year 2008, what is the difference between the Survival Rate(%) of Bolivia and Survival Rate(%) of Norway?
Offer a terse response. -15.4. In the year 2008, what is the difference between the Survival Rate(%) in Malaysia and Survival Rate(%) in Mauritius?
Your response must be concise. -0.29. In the year 2008, what is the difference between the Survival Rate(%) in Malaysia and Survival Rate(%) in Norway?
Your answer should be compact. -0.84. In the year 2008, what is the difference between the Survival Rate(%) in Mauritius and Survival Rate(%) in Norway?
Your answer should be compact. -0.55. In the year 2009, what is the difference between the Survival Rate(%) in Bolivia and Survival Rate(%) in Malaysia?
Your answer should be compact. -12.42. In the year 2009, what is the difference between the Survival Rate(%) of Bolivia and Survival Rate(%) of Mauritius?
Your answer should be very brief. -9.58. In the year 2009, what is the difference between the Survival Rate(%) of Bolivia and Survival Rate(%) of Norway?
Offer a terse response. -12.07. In the year 2009, what is the difference between the Survival Rate(%) in Malaysia and Survival Rate(%) in Mauritius?
Give a very brief answer. 2.83. In the year 2009, what is the difference between the Survival Rate(%) in Malaysia and Survival Rate(%) in Norway?
Your answer should be very brief. 0.35. In the year 2009, what is the difference between the Survival Rate(%) of Mauritius and Survival Rate(%) of Norway?
Ensure brevity in your answer.  -2.49. In the year 2010, what is the difference between the Survival Rate(%) of Bolivia and Survival Rate(%) of Malaysia?
Make the answer very short. -10.32. In the year 2010, what is the difference between the Survival Rate(%) of Bolivia and Survival Rate(%) of Mauritius?
Keep it short and to the point. -8.86. In the year 2010, what is the difference between the Survival Rate(%) in Bolivia and Survival Rate(%) in Norway?
Provide a succinct answer. -10. In the year 2010, what is the difference between the Survival Rate(%) of Malaysia and Survival Rate(%) of Mauritius?
Ensure brevity in your answer.  1.47. In the year 2010, what is the difference between the Survival Rate(%) in Malaysia and Survival Rate(%) in Norway?
Your response must be concise. 0.32. In the year 2010, what is the difference between the Survival Rate(%) in Mauritius and Survival Rate(%) in Norway?
Your answer should be compact. -1.15. In the year 2011, what is the difference between the Survival Rate(%) in Bolivia and Survival Rate(%) in Malaysia?
Give a very brief answer. -7.25. In the year 2011, what is the difference between the Survival Rate(%) of Bolivia and Survival Rate(%) of Mauritius?
Your response must be concise. -6.2. In the year 2011, what is the difference between the Survival Rate(%) of Bolivia and Survival Rate(%) of Norway?
Your answer should be compact. -7.15. In the year 2011, what is the difference between the Survival Rate(%) in Malaysia and Survival Rate(%) in Mauritius?
Offer a very short reply. 1.05. In the year 2011, what is the difference between the Survival Rate(%) of Malaysia and Survival Rate(%) of Norway?
Your response must be concise. 0.11. In the year 2011, what is the difference between the Survival Rate(%) in Mauritius and Survival Rate(%) in Norway?
Offer a very short reply. -0.94. What is the ratio of the Survival Rate(%) of Bolivia in 2001 to that in 2002?
Your answer should be very brief. 1.03. What is the ratio of the Survival Rate(%) of Malaysia in 2001 to that in 2002?
Give a very brief answer. 0.9. What is the ratio of the Survival Rate(%) in Mauritius in 2001 to that in 2002?
Keep it short and to the point. 1. What is the ratio of the Survival Rate(%) in Norway in 2001 to that in 2002?
Your answer should be very brief. 1.01. What is the ratio of the Survival Rate(%) of Bolivia in 2001 to that in 2006?
Offer a very short reply. 1. What is the ratio of the Survival Rate(%) of Malaysia in 2001 to that in 2006?
Offer a terse response. 0.93. What is the ratio of the Survival Rate(%) in Mauritius in 2001 to that in 2006?
Your answer should be very brief. 1. What is the ratio of the Survival Rate(%) in Norway in 2001 to that in 2006?
Make the answer very short. 1.01. What is the ratio of the Survival Rate(%) in Bolivia in 2001 to that in 2007?
Your response must be concise. 0.99. What is the ratio of the Survival Rate(%) in Malaysia in 2001 to that in 2007?
Make the answer very short. 0.9. What is the ratio of the Survival Rate(%) of Mauritius in 2001 to that in 2007?
Keep it short and to the point. 1.01. What is the ratio of the Survival Rate(%) in Norway in 2001 to that in 2007?
Offer a terse response. 1. What is the ratio of the Survival Rate(%) of Malaysia in 2001 to that in 2008?
Provide a short and direct response. 0.89. What is the ratio of the Survival Rate(%) of Norway in 2001 to that in 2008?
Your answer should be compact. 1.01. What is the ratio of the Survival Rate(%) of Bolivia in 2001 to that in 2009?
Your response must be concise. 0.96. What is the ratio of the Survival Rate(%) in Malaysia in 2001 to that in 2009?
Give a very brief answer. 0.87. What is the ratio of the Survival Rate(%) of Mauritius in 2001 to that in 2009?
Offer a terse response. 1.01. What is the ratio of the Survival Rate(%) in Bolivia in 2001 to that in 2010?
Provide a succinct answer. 0.93. What is the ratio of the Survival Rate(%) of Malaysia in 2001 to that in 2010?
Provide a succinct answer. 0.87. What is the ratio of the Survival Rate(%) of Norway in 2001 to that in 2010?
Give a very brief answer. 1. What is the ratio of the Survival Rate(%) of Bolivia in 2001 to that in 2011?
Your response must be concise. 0.9. What is the ratio of the Survival Rate(%) in Malaysia in 2001 to that in 2011?
Ensure brevity in your answer.  0.87. What is the ratio of the Survival Rate(%) in Mauritius in 2001 to that in 2011?
Ensure brevity in your answer.  0.99. What is the ratio of the Survival Rate(%) of Norway in 2001 to that in 2011?
Provide a short and direct response. 1. What is the ratio of the Survival Rate(%) in Malaysia in 2002 to that in 2006?
Offer a terse response. 1.04. What is the ratio of the Survival Rate(%) in Norway in 2002 to that in 2006?
Provide a short and direct response. 1. What is the ratio of the Survival Rate(%) of Bolivia in 2002 to that in 2007?
Offer a very short reply. 0.96. What is the ratio of the Survival Rate(%) in Mauritius in 2002 to that in 2007?
Give a very brief answer. 1.02. What is the ratio of the Survival Rate(%) of Norway in 2002 to that in 2007?
Offer a terse response. 0.99. What is the ratio of the Survival Rate(%) in Bolivia in 2002 to that in 2008?
Offer a terse response. 0.97. What is the ratio of the Survival Rate(%) in Malaysia in 2002 to that in 2008?
Give a very brief answer. 0.99. What is the ratio of the Survival Rate(%) of Bolivia in 2002 to that in 2009?
Ensure brevity in your answer.  0.92. What is the ratio of the Survival Rate(%) of Malaysia in 2002 to that in 2009?
Your answer should be compact. 0.98. What is the ratio of the Survival Rate(%) in Mauritius in 2002 to that in 2009?
Your answer should be very brief. 1.01. What is the ratio of the Survival Rate(%) of Norway in 2002 to that in 2009?
Keep it short and to the point. 0.99. What is the ratio of the Survival Rate(%) of Bolivia in 2002 to that in 2010?
Make the answer very short. 0.9. What is the ratio of the Survival Rate(%) in Malaysia in 2002 to that in 2010?
Make the answer very short. 0.97. What is the ratio of the Survival Rate(%) in Norway in 2002 to that in 2010?
Ensure brevity in your answer.  0.99. What is the ratio of the Survival Rate(%) of Bolivia in 2002 to that in 2011?
Ensure brevity in your answer.  0.87. What is the ratio of the Survival Rate(%) in Malaysia in 2002 to that in 2011?
Provide a succinct answer. 0.98. What is the ratio of the Survival Rate(%) in Norway in 2002 to that in 2011?
Your response must be concise. 0.99. What is the ratio of the Survival Rate(%) in Bolivia in 2006 to that in 2007?
Give a very brief answer. 0.98. What is the ratio of the Survival Rate(%) of Malaysia in 2006 to that in 2007?
Your answer should be very brief. 0.97. What is the ratio of the Survival Rate(%) of Mauritius in 2006 to that in 2007?
Make the answer very short. 1.02. What is the ratio of the Survival Rate(%) in Norway in 2006 to that in 2007?
Offer a terse response. 1. What is the ratio of the Survival Rate(%) in Malaysia in 2006 to that in 2008?
Provide a short and direct response. 0.95. What is the ratio of the Survival Rate(%) in Mauritius in 2006 to that in 2008?
Ensure brevity in your answer.  1. What is the ratio of the Survival Rate(%) in Norway in 2006 to that in 2008?
Make the answer very short. 1. What is the ratio of the Survival Rate(%) of Bolivia in 2006 to that in 2009?
Make the answer very short. 0.95. What is the ratio of the Survival Rate(%) of Malaysia in 2006 to that in 2009?
Provide a short and direct response. 0.94. What is the ratio of the Survival Rate(%) in Mauritius in 2006 to that in 2009?
Your answer should be compact. 1.01. What is the ratio of the Survival Rate(%) in Bolivia in 2006 to that in 2010?
Offer a very short reply. 0.93. What is the ratio of the Survival Rate(%) of Malaysia in 2006 to that in 2010?
Your answer should be very brief. 0.94. What is the ratio of the Survival Rate(%) in Mauritius in 2006 to that in 2010?
Ensure brevity in your answer.  1. What is the ratio of the Survival Rate(%) in Norway in 2006 to that in 2010?
Provide a succinct answer. 1. What is the ratio of the Survival Rate(%) in Bolivia in 2006 to that in 2011?
Offer a very short reply. 0.9. What is the ratio of the Survival Rate(%) of Malaysia in 2006 to that in 2011?
Your response must be concise. 0.94. What is the ratio of the Survival Rate(%) in Mauritius in 2006 to that in 2011?
Keep it short and to the point. 1. What is the ratio of the Survival Rate(%) of Bolivia in 2007 to that in 2008?
Offer a very short reply. 1.01. What is the ratio of the Survival Rate(%) in Mauritius in 2007 to that in 2008?
Ensure brevity in your answer.  0.98. What is the ratio of the Survival Rate(%) in Norway in 2007 to that in 2008?
Offer a very short reply. 1. What is the ratio of the Survival Rate(%) of Bolivia in 2007 to that in 2009?
Your response must be concise. 0.97. What is the ratio of the Survival Rate(%) in Malaysia in 2007 to that in 2009?
Your response must be concise. 0.97. What is the ratio of the Survival Rate(%) of Bolivia in 2007 to that in 2010?
Ensure brevity in your answer.  0.94. What is the ratio of the Survival Rate(%) in Malaysia in 2007 to that in 2010?
Provide a short and direct response. 0.97. What is the ratio of the Survival Rate(%) of Mauritius in 2007 to that in 2010?
Provide a succinct answer. 0.98. What is the ratio of the Survival Rate(%) of Norway in 2007 to that in 2010?
Give a very brief answer. 1. What is the ratio of the Survival Rate(%) of Bolivia in 2007 to that in 2011?
Offer a terse response. 0.91. What is the ratio of the Survival Rate(%) in Malaysia in 2007 to that in 2011?
Offer a very short reply. 0.97. What is the ratio of the Survival Rate(%) in Mauritius in 2007 to that in 2011?
Offer a terse response. 0.98. What is the ratio of the Survival Rate(%) of Malaysia in 2008 to that in 2009?
Give a very brief answer. 0.98. What is the ratio of the Survival Rate(%) of Mauritius in 2008 to that in 2009?
Your response must be concise. 1.02. What is the ratio of the Survival Rate(%) of Bolivia in 2008 to that in 2010?
Offer a terse response. 0.93. What is the ratio of the Survival Rate(%) of Malaysia in 2008 to that in 2010?
Your response must be concise. 0.98. What is the ratio of the Survival Rate(%) in Mauritius in 2008 to that in 2010?
Your answer should be compact. 1. What is the ratio of the Survival Rate(%) in Bolivia in 2008 to that in 2011?
Make the answer very short. 0.91. What is the ratio of the Survival Rate(%) of Malaysia in 2008 to that in 2011?
Offer a terse response. 0.99. What is the ratio of the Survival Rate(%) of Mauritius in 2008 to that in 2011?
Keep it short and to the point. 1. What is the ratio of the Survival Rate(%) of Malaysia in 2009 to that in 2010?
Make the answer very short. 1. What is the ratio of the Survival Rate(%) of Mauritius in 2009 to that in 2010?
Provide a succinct answer. 0.99. What is the ratio of the Survival Rate(%) in Bolivia in 2009 to that in 2011?
Offer a very short reply. 0.95. What is the ratio of the Survival Rate(%) in Mauritius in 2009 to that in 2011?
Your answer should be compact. 0.98. What is the ratio of the Survival Rate(%) in Norway in 2009 to that in 2011?
Provide a short and direct response. 1. What is the ratio of the Survival Rate(%) of Bolivia in 2010 to that in 2011?
Your response must be concise. 0.97. What is the ratio of the Survival Rate(%) of Mauritius in 2010 to that in 2011?
Offer a very short reply. 1. What is the ratio of the Survival Rate(%) of Norway in 2010 to that in 2011?
Provide a short and direct response. 1. What is the difference between the highest and the second highest Survival Rate(%) in Bolivia?
Make the answer very short. 2.83. What is the difference between the highest and the second highest Survival Rate(%) in Malaysia?
Offer a very short reply. 0.05. What is the difference between the highest and the second highest Survival Rate(%) of Mauritius?
Ensure brevity in your answer.  0.1. What is the difference between the highest and the second highest Survival Rate(%) in Norway?
Keep it short and to the point. 0.32. What is the difference between the highest and the lowest Survival Rate(%) in Bolivia?
Your answer should be very brief. 11.57. What is the difference between the highest and the lowest Survival Rate(%) of Malaysia?
Provide a short and direct response. 12.73. What is the difference between the highest and the lowest Survival Rate(%) of Mauritius?
Your response must be concise. 1.9. What is the difference between the highest and the lowest Survival Rate(%) of Norway?
Your answer should be compact. 1.15. 